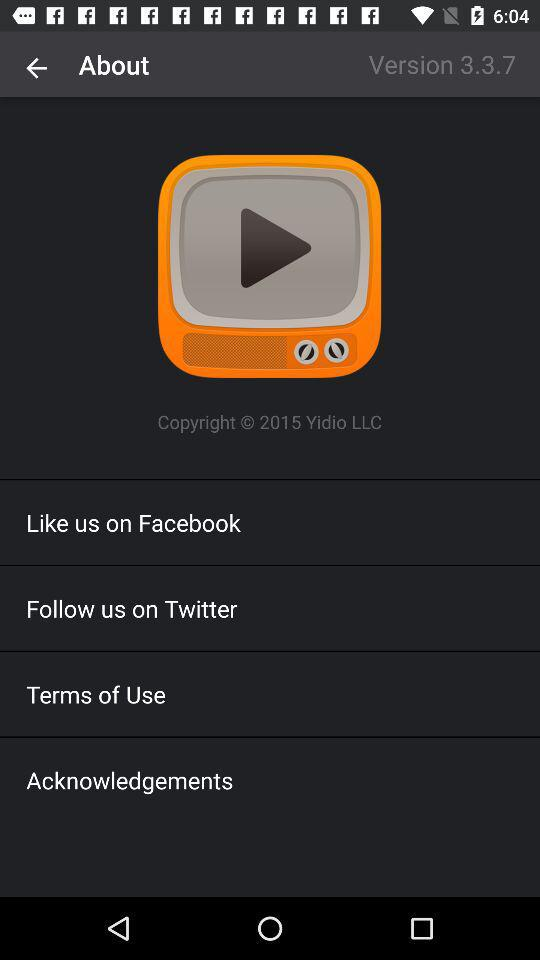Where can a user follow? A user can follow on Twitter. 